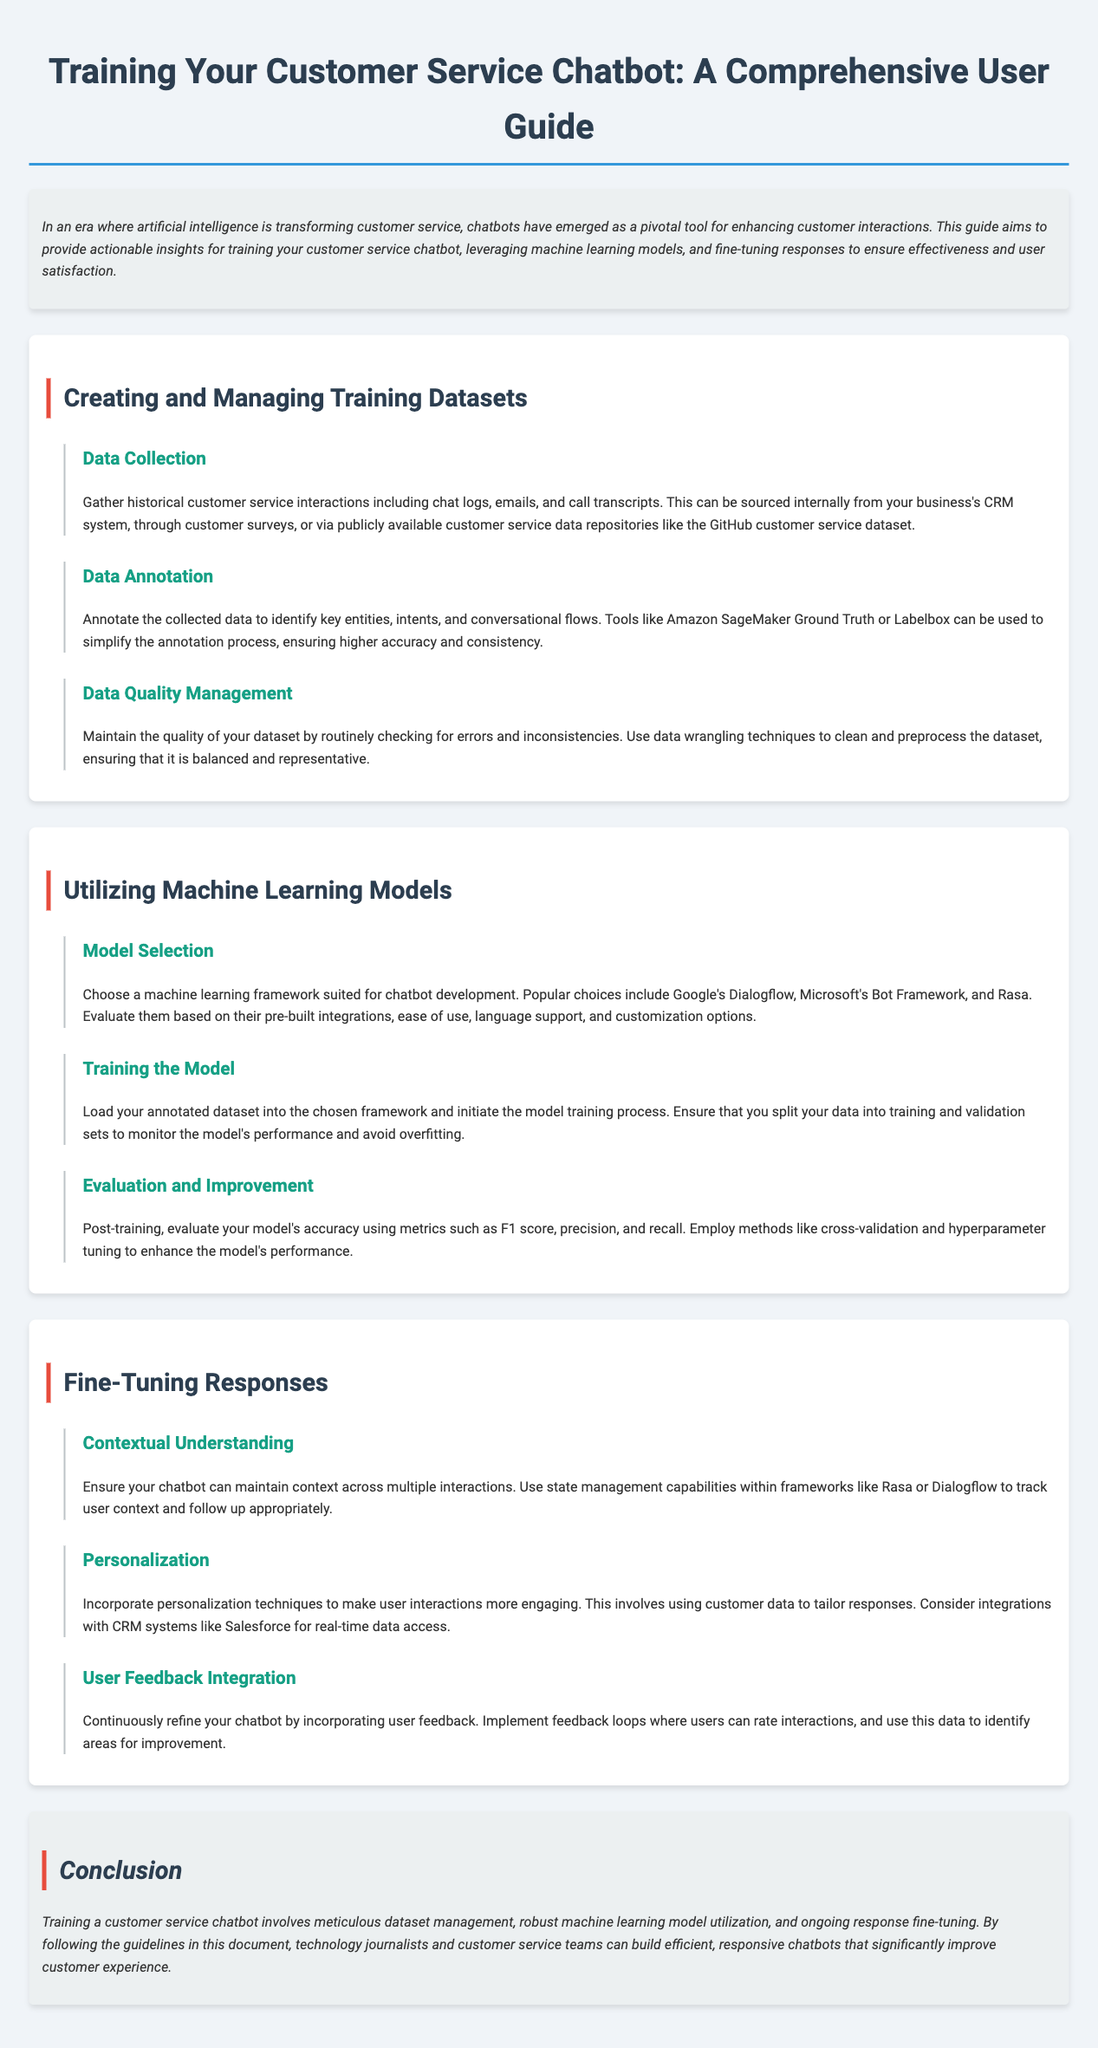What is the main purpose of the guide? The guide aims to provide actionable insights for training customer service chatbots, leveraging machine learning models, and fine-tuning responses.
Answer: Actionable insights for training chatbots What tool can be used for data annotation? Tools like Amazon SageMaker Ground Truth or Labelbox can be used to simplify the annotation process.
Answer: Amazon SageMaker Ground Truth or Labelbox What is the first step in creating a training dataset? Gather historical customer service interactions including chat logs, emails, and call transcripts.
Answer: Data Collection What framework is mentioned for model selection? Popular choices include Google's Dialogflow, Microsoft's Bot Framework, and Rasa.
Answer: Google's Dialogflow, Microsoft's Bot Framework, and Rasa What technique should be used for evaluating the model's accuracy? Use metrics such as F1 score, precision, and recall.
Answer: F1 score, precision, and recall Which method helps maintain context in chatbot interactions? Use state management capabilities within frameworks like Rasa or Dialogflow.
Answer: State management What aspect of user interactions can be improved through personalization? Incorporate personalized techniques to make user interactions more engaging.
Answer: Personalization How should user feedback be utilized? Implement feedback loops where users can rate interactions to identify areas for improvement.
Answer: Feedback loops What does maintaining data quality involve? Checking for errors and inconsistencies, and using data wrangling techniques to clean and preprocess the dataset.
Answer: Checking for errors and inconsistencies 